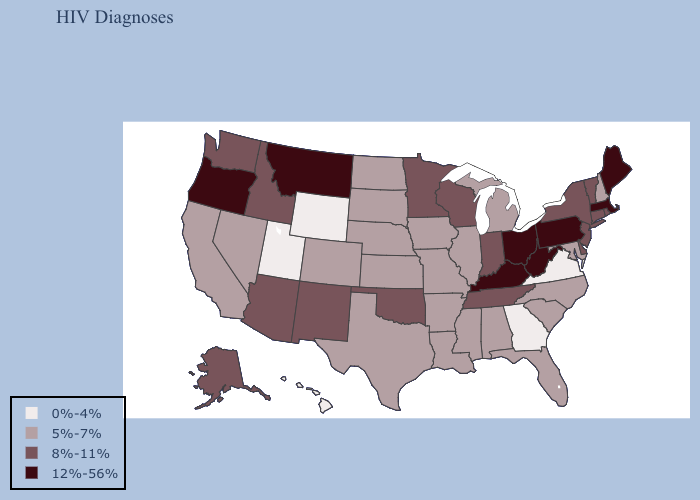Which states have the lowest value in the South?
Concise answer only. Georgia, Virginia. Name the states that have a value in the range 8%-11%?
Give a very brief answer. Alaska, Arizona, Connecticut, Delaware, Idaho, Indiana, Minnesota, New Jersey, New Mexico, New York, Oklahoma, Rhode Island, Tennessee, Vermont, Washington, Wisconsin. Among the states that border Iowa , which have the highest value?
Give a very brief answer. Minnesota, Wisconsin. Does the map have missing data?
Keep it brief. No. Among the states that border Vermont , which have the lowest value?
Short answer required. New Hampshire. Name the states that have a value in the range 5%-7%?
Write a very short answer. Alabama, Arkansas, California, Colorado, Florida, Illinois, Iowa, Kansas, Louisiana, Maryland, Michigan, Mississippi, Missouri, Nebraska, Nevada, New Hampshire, North Carolina, North Dakota, South Carolina, South Dakota, Texas. What is the lowest value in the USA?
Be succinct. 0%-4%. What is the value of Rhode Island?
Concise answer only. 8%-11%. What is the lowest value in the USA?
Answer briefly. 0%-4%. Does Tennessee have a lower value than Indiana?
Keep it brief. No. Does Missouri have the highest value in the MidWest?
Be succinct. No. What is the lowest value in the South?
Give a very brief answer. 0%-4%. Name the states that have a value in the range 5%-7%?
Keep it brief. Alabama, Arkansas, California, Colorado, Florida, Illinois, Iowa, Kansas, Louisiana, Maryland, Michigan, Mississippi, Missouri, Nebraska, Nevada, New Hampshire, North Carolina, North Dakota, South Carolina, South Dakota, Texas. Does the map have missing data?
Quick response, please. No. Is the legend a continuous bar?
Concise answer only. No. 